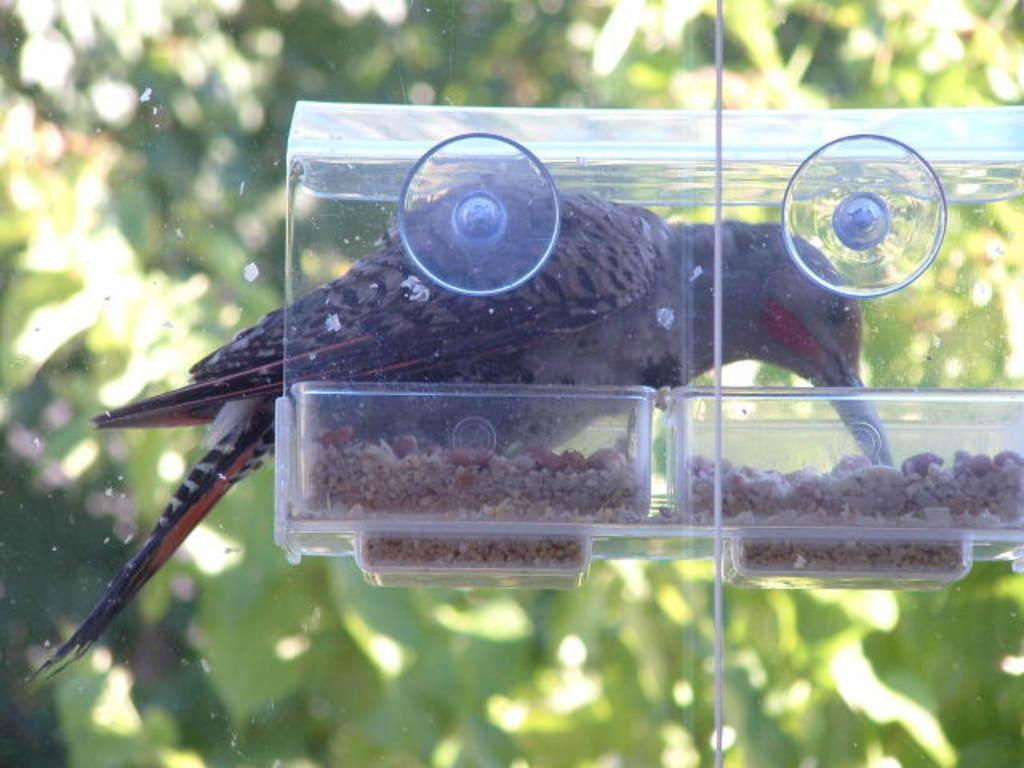Please provide a concise description of this image. In this image we can see a bird and also the bird feeder. In the background we can see the leaves. 